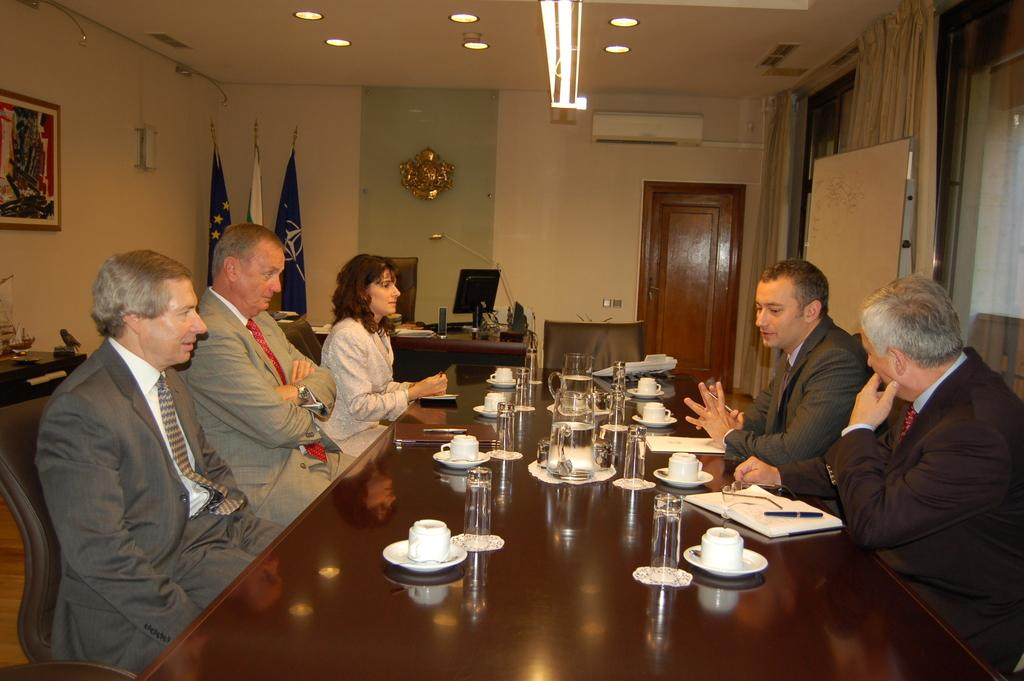How many people are sitting on chairs in the image? There are five people sitting on chairs in the image. What objects can be seen on the table? There is a cup, a saucer, a glass, a book, and a pen on the table. What is located at the back side of the image? At the back side, there is a system and a flag. Can you see any umbrellas being used by the people in the image? There are no umbrellas visible in the image. Is there a church depicted in the background of the image? There is no church present in the image. 